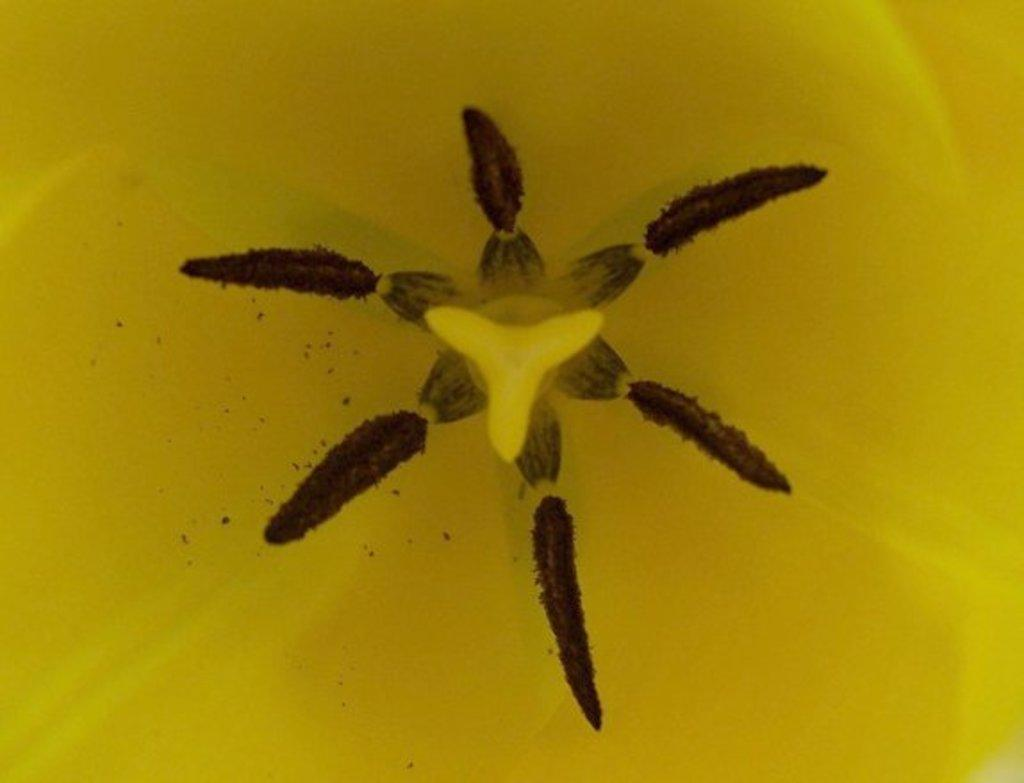What type of flower can be seen in the image? There is there a yellow color flower in the image? What type of meat is being cooked in the image? There is no meat present in the image, as it only features a yellow color flower. What type of tank is visible in the image? There is no tank present in the image, as it only features a yellow color flower. 